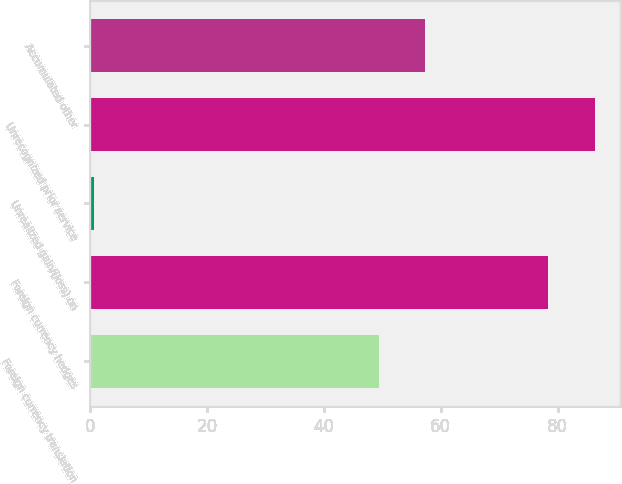Convert chart to OTSL. <chart><loc_0><loc_0><loc_500><loc_500><bar_chart><fcel>Foreign currency translation<fcel>Foreign currency hedges<fcel>Unrealized gain/(loss) on<fcel>Unrecognized prior service<fcel>Accumulated other<nl><fcel>49.4<fcel>78.4<fcel>0.6<fcel>86.33<fcel>57.33<nl></chart> 